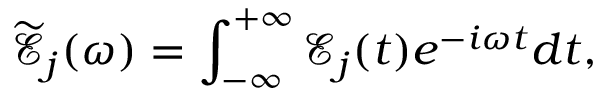<formula> <loc_0><loc_0><loc_500><loc_500>\mathcal { \widetilde { E } } _ { j } ( \omega ) = \int _ { - \infty } ^ { + \infty } \mathcal { E } _ { j } ( t ) e ^ { - i \omega t } d t ,</formula> 